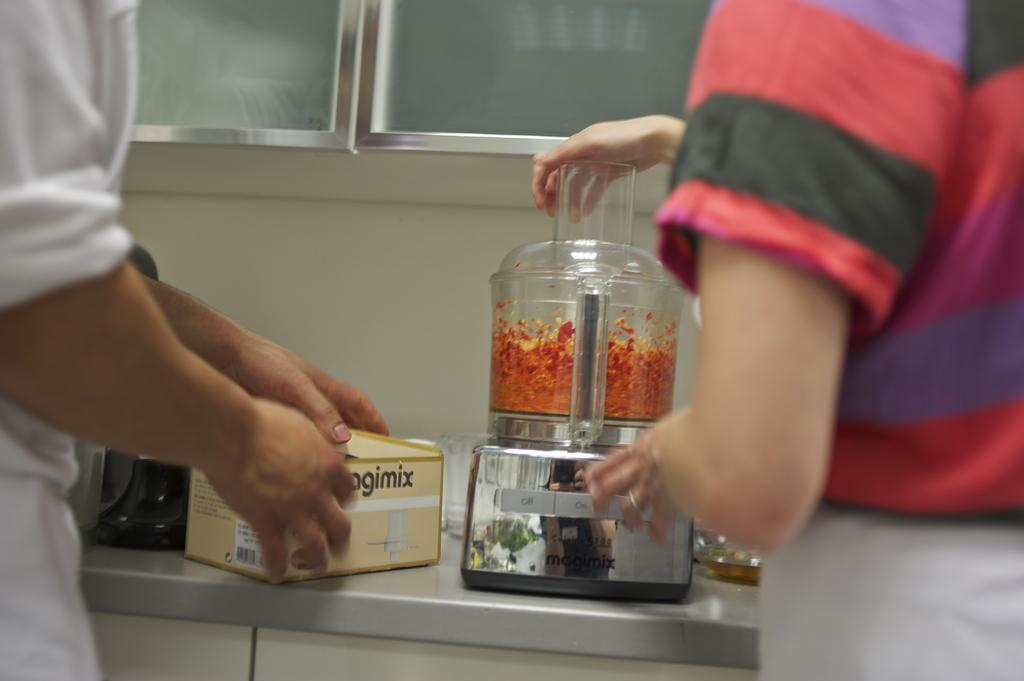<image>
Present a compact description of the photo's key features. a lady putting some orange items in a blender with a mix box next to it 